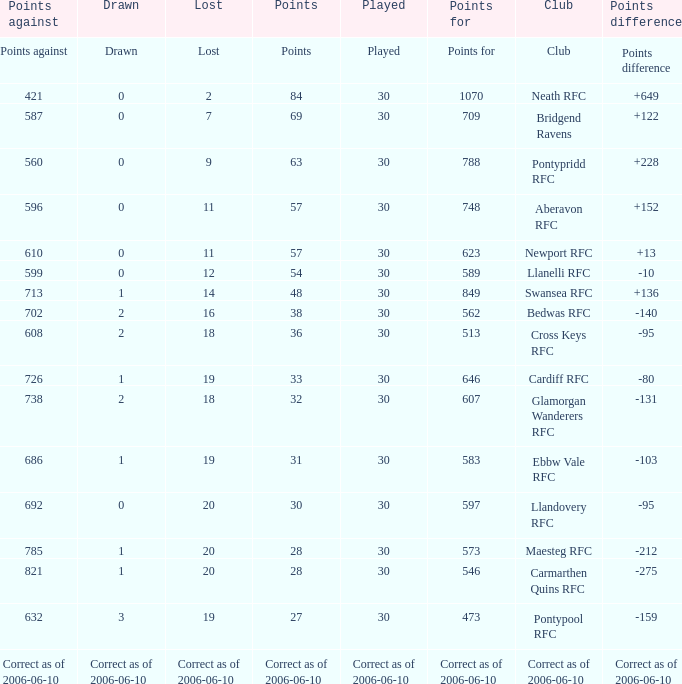What is Drawn, when Points Against is "686"? 1.0. 